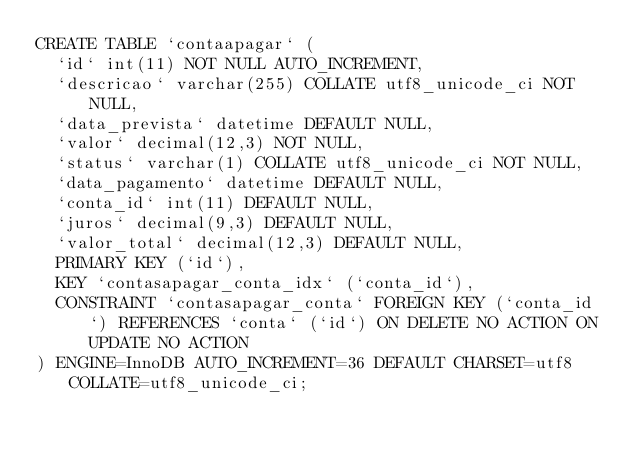<code> <loc_0><loc_0><loc_500><loc_500><_SQL_>CREATE TABLE `contaapagar` (
  `id` int(11) NOT NULL AUTO_INCREMENT,
  `descricao` varchar(255) COLLATE utf8_unicode_ci NOT NULL,
  `data_prevista` datetime DEFAULT NULL,
  `valor` decimal(12,3) NOT NULL,
  `status` varchar(1) COLLATE utf8_unicode_ci NOT NULL,
  `data_pagamento` datetime DEFAULT NULL,
  `conta_id` int(11) DEFAULT NULL,
  `juros` decimal(9,3) DEFAULT NULL,
  `valor_total` decimal(12,3) DEFAULT NULL,
  PRIMARY KEY (`id`),
  KEY `contasapagar_conta_idx` (`conta_id`),
  CONSTRAINT `contasapagar_conta` FOREIGN KEY (`conta_id`) REFERENCES `conta` (`id`) ON DELETE NO ACTION ON UPDATE NO ACTION
) ENGINE=InnoDB AUTO_INCREMENT=36 DEFAULT CHARSET=utf8 COLLATE=utf8_unicode_ci;
</code> 